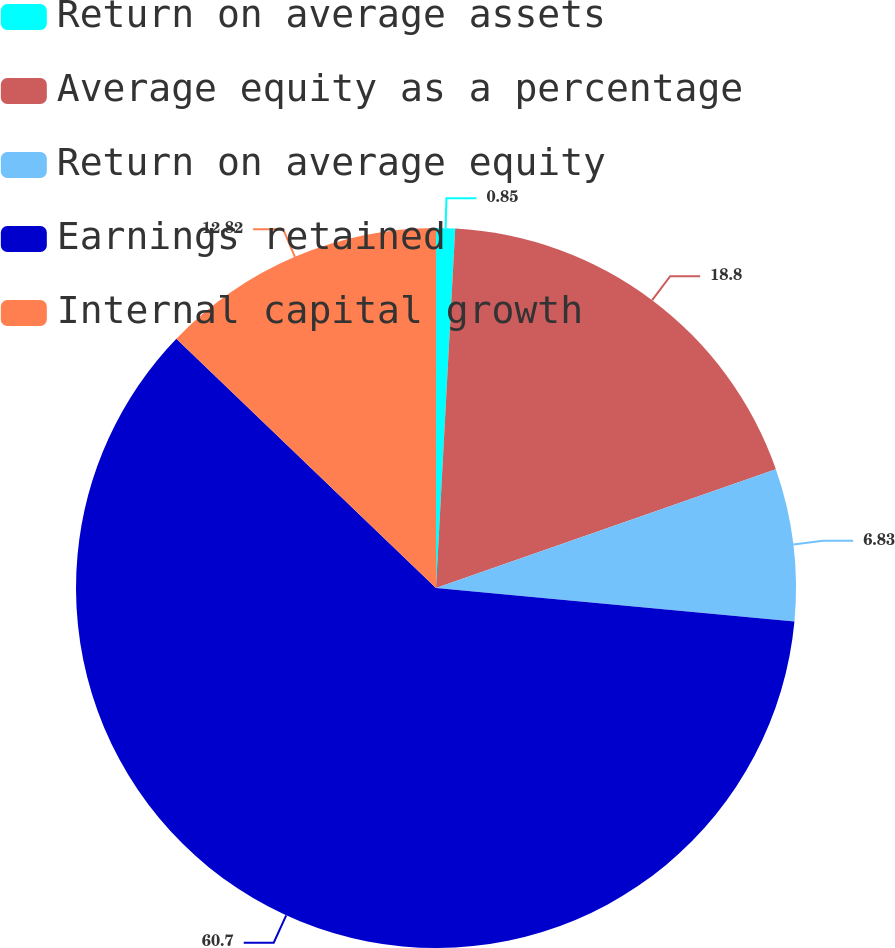Convert chart to OTSL. <chart><loc_0><loc_0><loc_500><loc_500><pie_chart><fcel>Return on average assets<fcel>Average equity as a percentage<fcel>Return on average equity<fcel>Earnings retained<fcel>Internal capital growth<nl><fcel>0.85%<fcel>18.8%<fcel>6.83%<fcel>60.69%<fcel>12.82%<nl></chart> 